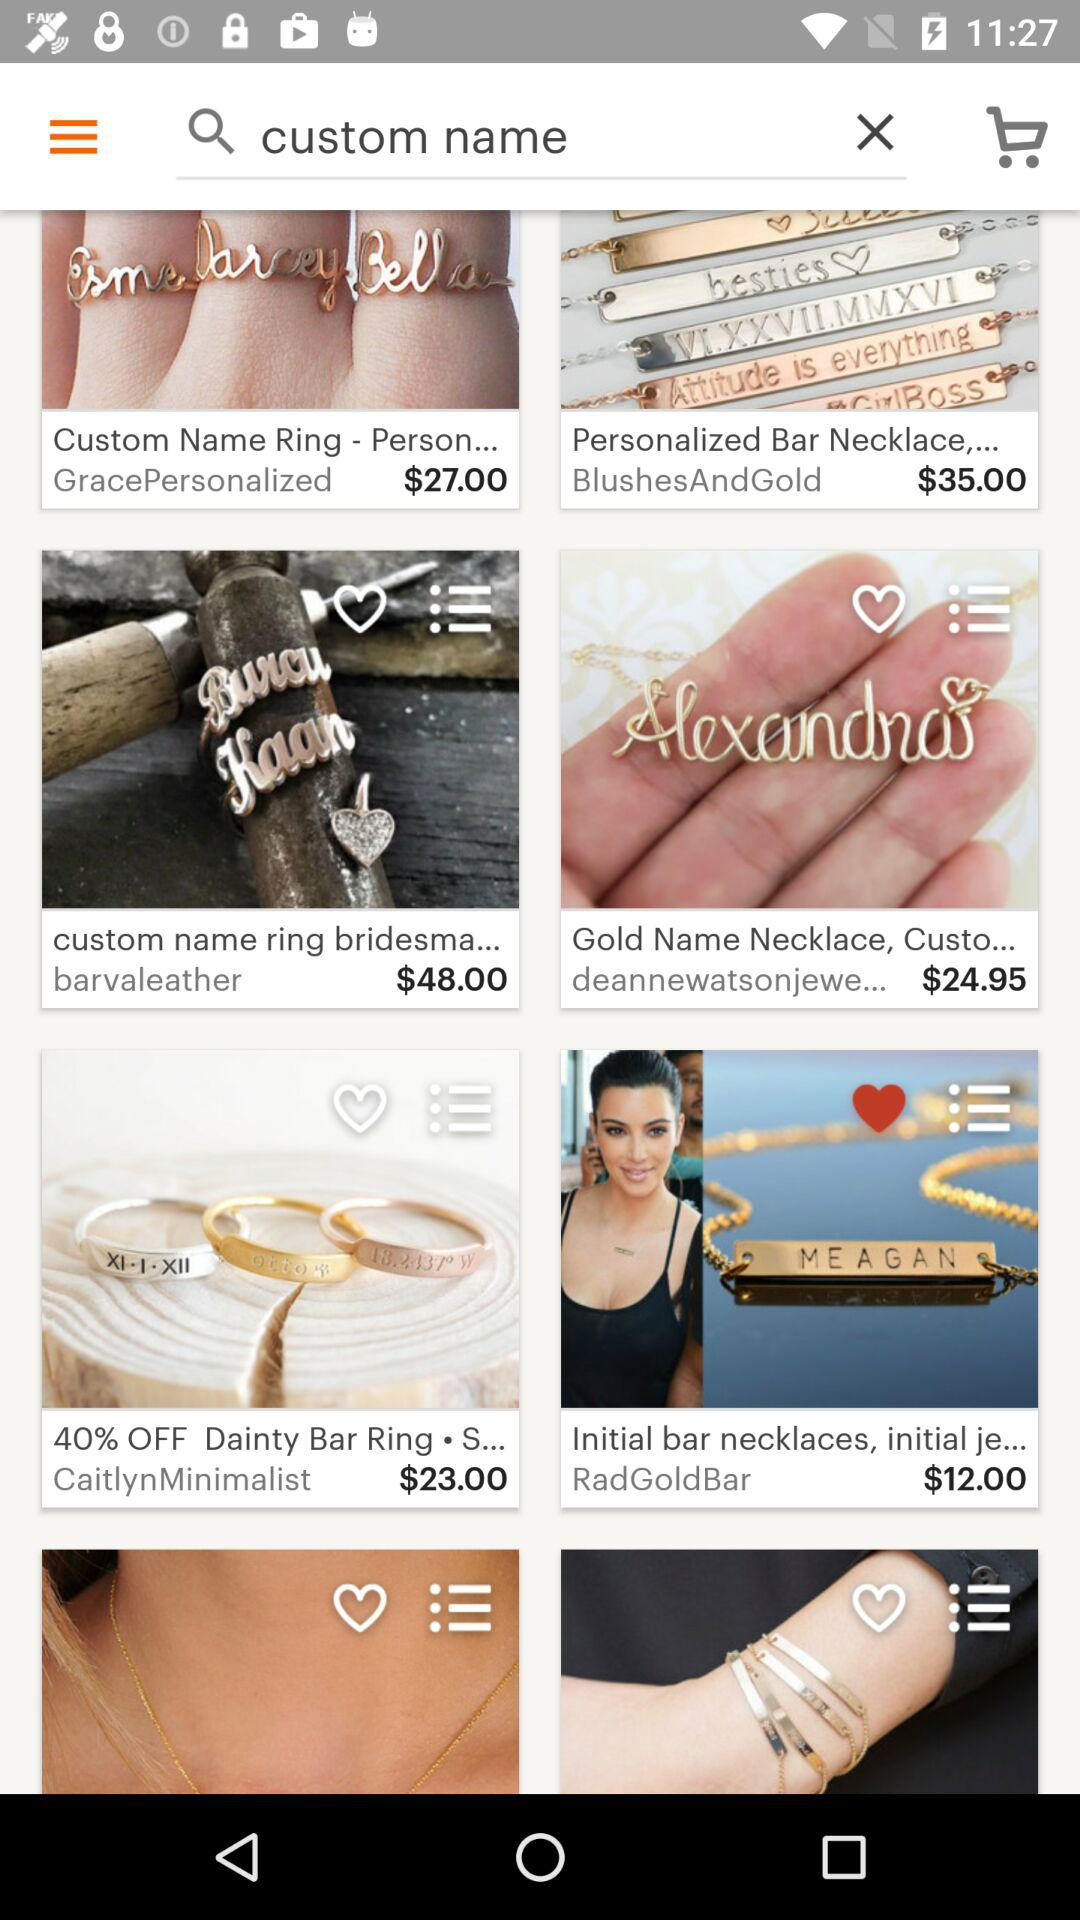How much is the most expensive item?
Answer the question using a single word or phrase. $48.00 